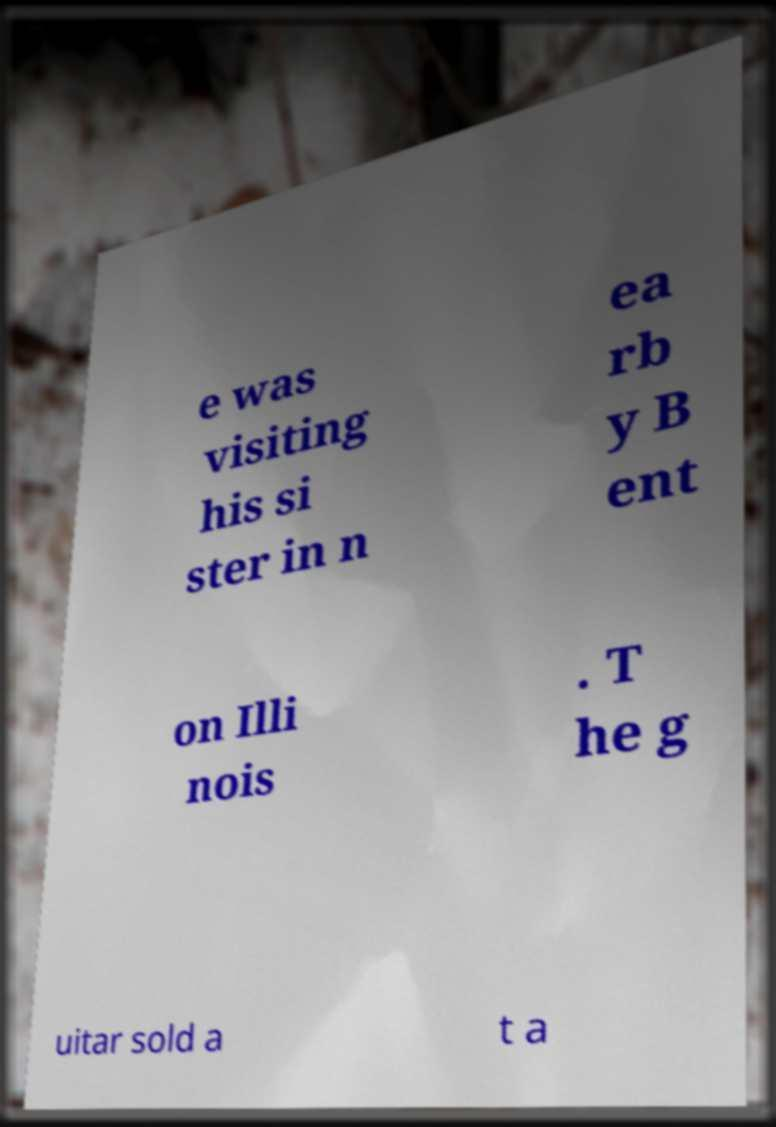Could you extract and type out the text from this image? e was visiting his si ster in n ea rb y B ent on Illi nois . T he g uitar sold a t a 